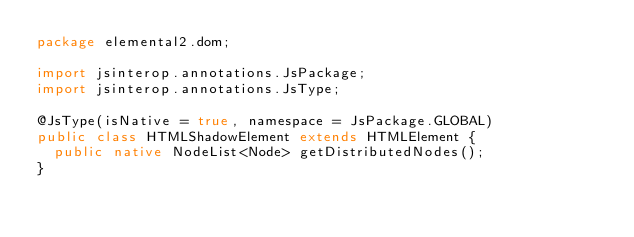<code> <loc_0><loc_0><loc_500><loc_500><_Java_>package elemental2.dom;

import jsinterop.annotations.JsPackage;
import jsinterop.annotations.JsType;

@JsType(isNative = true, namespace = JsPackage.GLOBAL)
public class HTMLShadowElement extends HTMLElement {
  public native NodeList<Node> getDistributedNodes();
}
</code> 